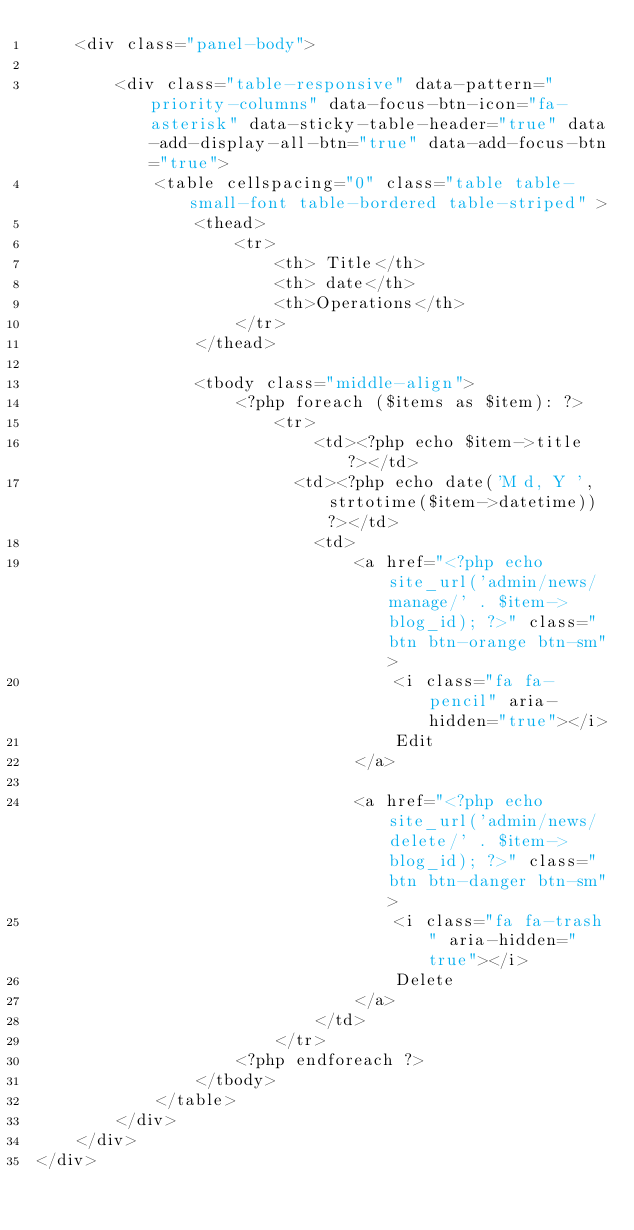Convert code to text. <code><loc_0><loc_0><loc_500><loc_500><_PHP_>    <div class="panel-body">

        <div class="table-responsive" data-pattern="priority-columns" data-focus-btn-icon="fa-asterisk" data-sticky-table-header="true" data-add-display-all-btn="true" data-add-focus-btn="true">
            <table cellspacing="0" class="table table-small-font table-bordered table-striped" >
                <thead>
                    <tr>
                        <th> Title</th>
                        <th> date</th>
                        <th>Operations</th>
                    </tr>
                </thead>

                <tbody class="middle-align">
                    <?php foreach ($items as $item): ?>
                        <tr>
                            <td><?php echo $item->title ?></td>
                          <td><?php echo date('M d, Y ', strtotime($item->datetime)) ?></td>
                            <td>
                                <a href="<?php echo site_url('admin/news/manage/' . $item->blog_id); ?>" class="btn btn-orange btn-sm">
                                    <i class="fa fa-pencil" aria-hidden="true"></i>
                                    Edit
                                </a>

                                <a href="<?php echo site_url('admin/news/delete/' . $item->blog_id); ?>" class="btn btn-danger btn-sm">
                                    <i class="fa fa-trash" aria-hidden="true"></i>
                                    Delete
                                </a>
                            </td>
                        </tr>
                    <?php endforeach ?>
                </tbody>
            </table>
        </div>
    </div>
</div>
</code> 